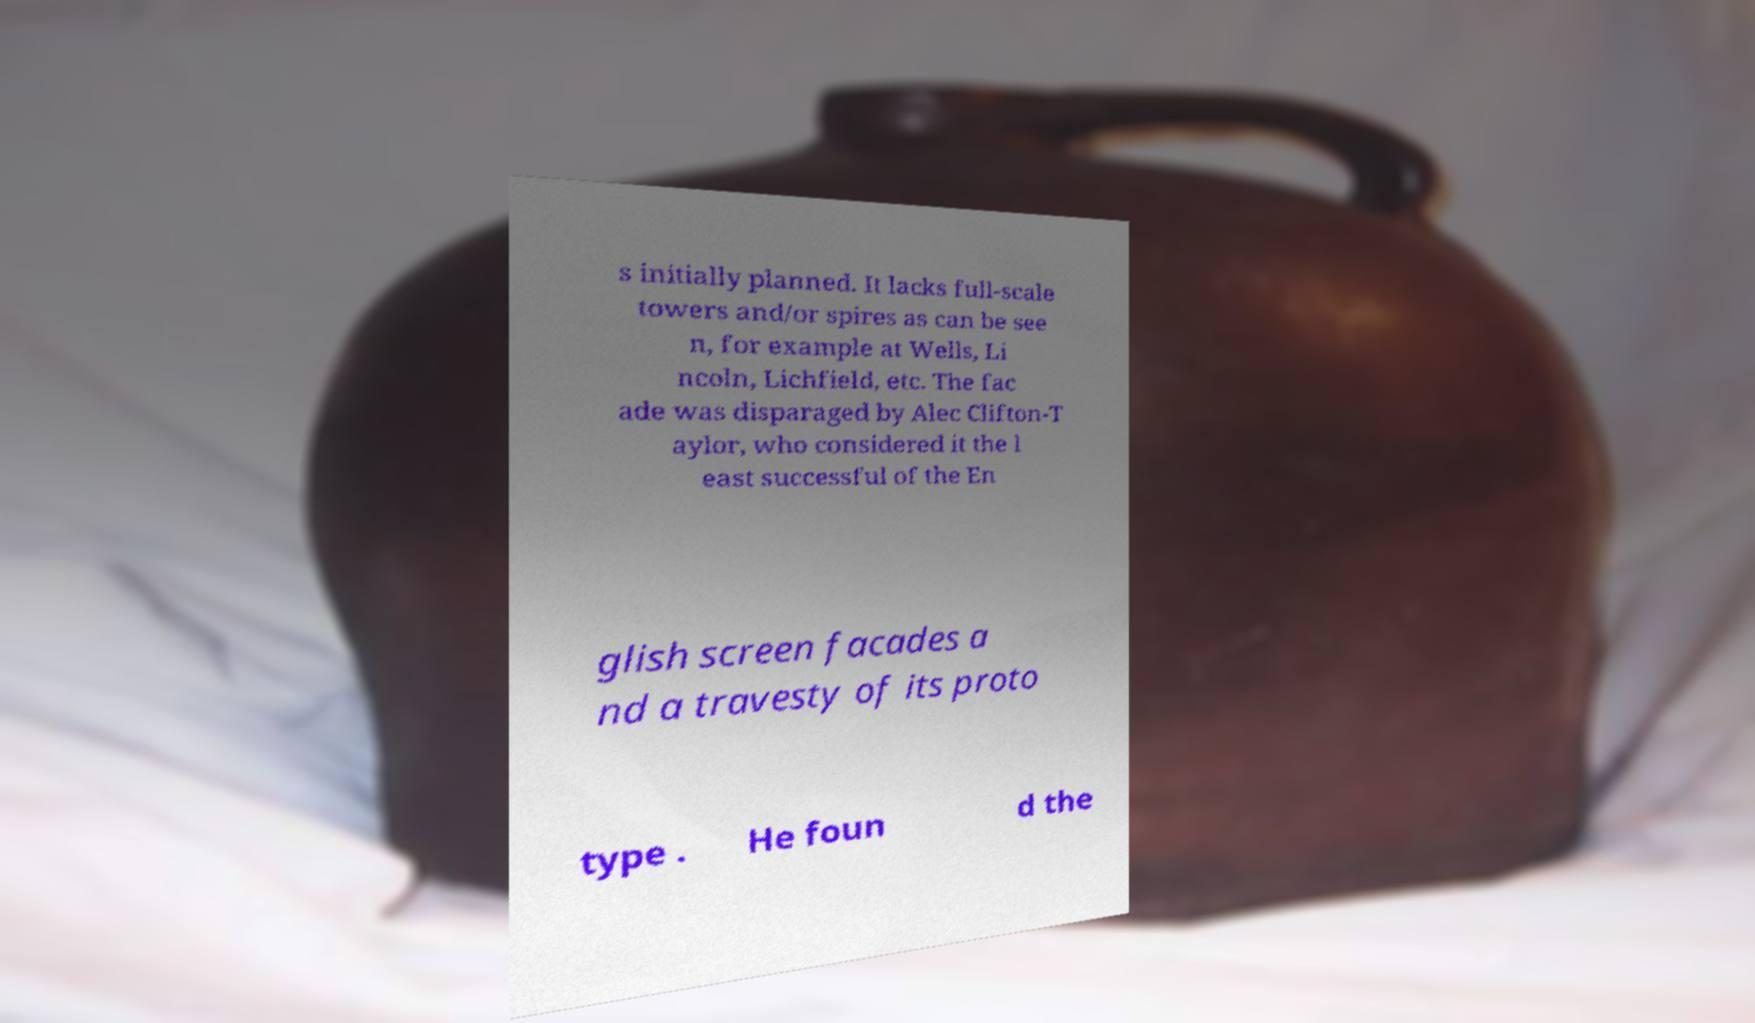Can you read and provide the text displayed in the image?This photo seems to have some interesting text. Can you extract and type it out for me? s initially planned. It lacks full-scale towers and/or spires as can be see n, for example at Wells, Li ncoln, Lichfield, etc. The fac ade was disparaged by Alec Clifton-T aylor, who considered it the l east successful of the En glish screen facades a nd a travesty of its proto type . He foun d the 